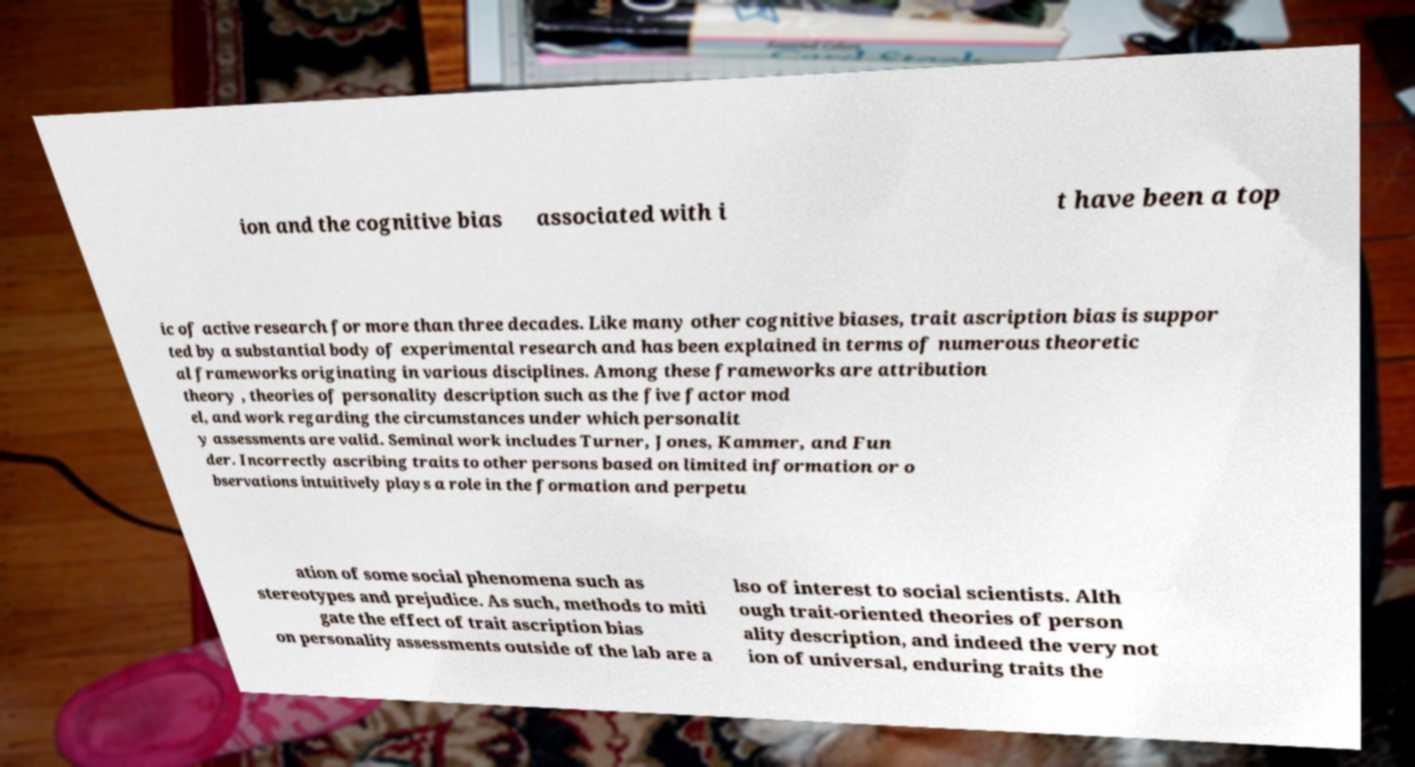There's text embedded in this image that I need extracted. Can you transcribe it verbatim? ion and the cognitive bias associated with i t have been a top ic of active research for more than three decades. Like many other cognitive biases, trait ascription bias is suppor ted by a substantial body of experimental research and has been explained in terms of numerous theoretic al frameworks originating in various disciplines. Among these frameworks are attribution theory , theories of personality description such as the five factor mod el, and work regarding the circumstances under which personalit y assessments are valid. Seminal work includes Turner, Jones, Kammer, and Fun der. Incorrectly ascribing traits to other persons based on limited information or o bservations intuitively plays a role in the formation and perpetu ation of some social phenomena such as stereotypes and prejudice. As such, methods to miti gate the effect of trait ascription bias on personality assessments outside of the lab are a lso of interest to social scientists. Alth ough trait-oriented theories of person ality description, and indeed the very not ion of universal, enduring traits the 